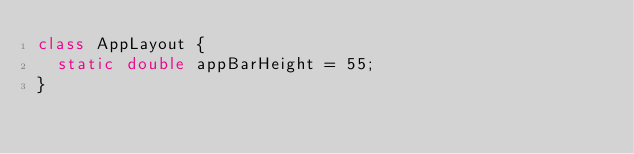Convert code to text. <code><loc_0><loc_0><loc_500><loc_500><_Dart_>class AppLayout {
  static double appBarHeight = 55;
}
</code> 